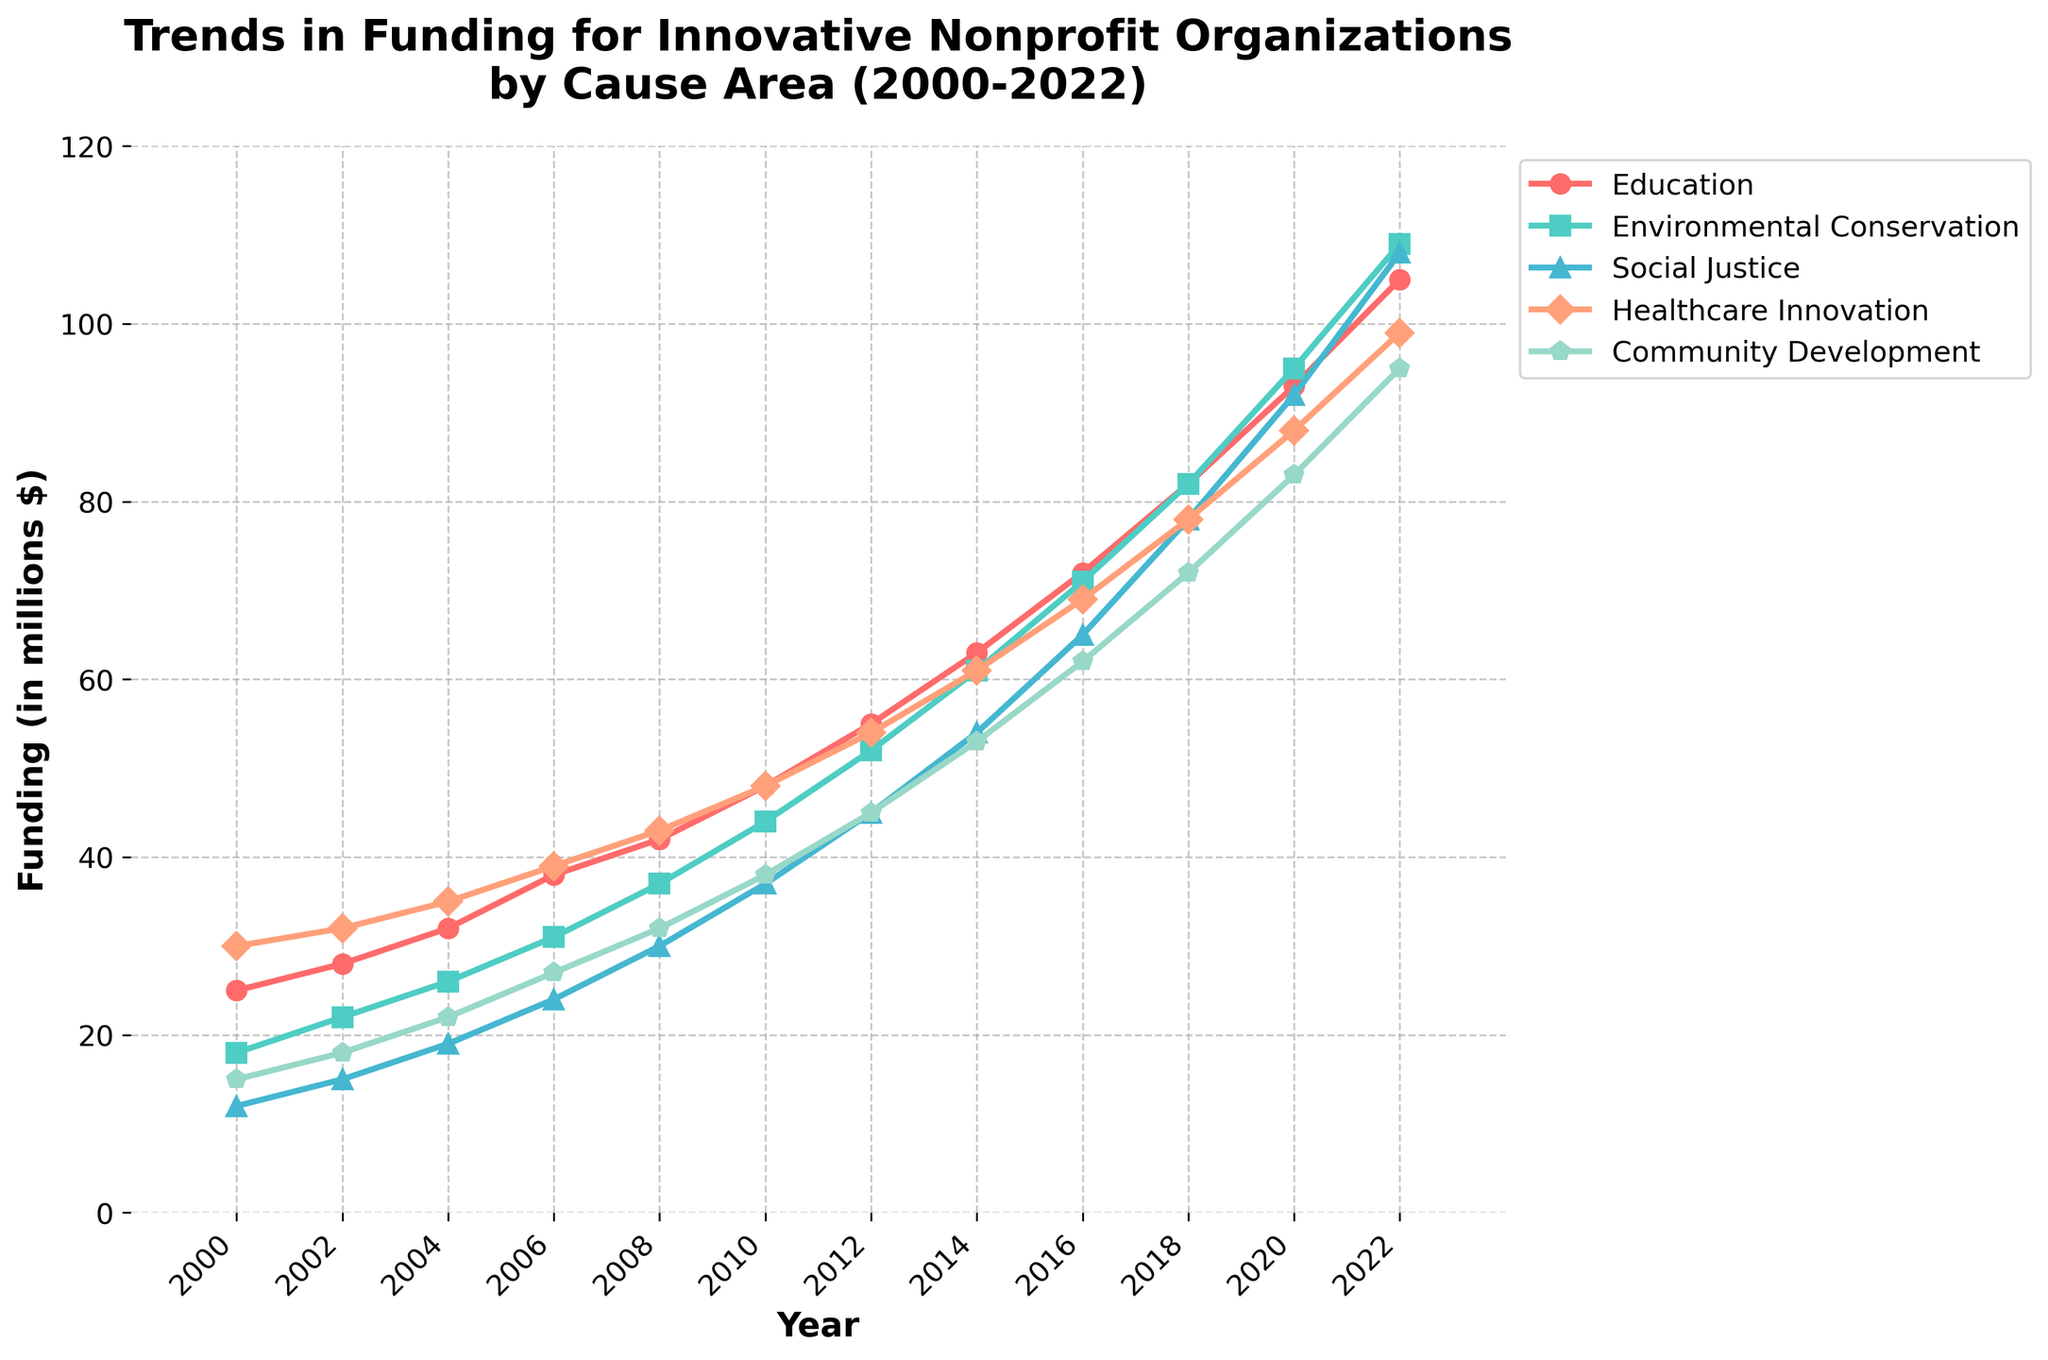What was the funding difference between Education and Healthcare Innovation in 2022? First, check the funding amounts for Education and Healthcare Innovation in 2022. Education has 105 million, and Healthcare Innovation has 99 million. The difference is: 105 - 99 = 6 million.
Answer: 6 million In which year did Environmental Conservation see the highest increase in funding compared to two years prior? Observe the data points for each year and calculate the increase from two years prior. The greatest increase is from 2020 to 2022 where the funding was 109 - 95 = 14 million.
Answer: 2022 In 2010, which cause area had the lowest funding and what was that amount? Refer to the data for 2010. Social Justice had the lowest funding with 37 million.
Answer: Social Justice, 37 million What's the difference between the highest and the lowest funding across all cause areas in 2022? Identify the highest and the lowest funding values in 2022. The highest is Environmental Conservation at 109 million, and the lowest is Social Justice at 95 million. The difference is: 109 - 95 = 14 million.
Answer: 14 million How many cause areas received more than 80 million in funding in 2020? Look at the 2020 data for each cause area. Education had 93, Environmental Conservation had 95, Social Justice had 92, and Healthcare Innovation had 88. So, there are 4 cause areas.
Answer: 4 By how much did funding for Community Development increase from 2000 to 2022? Community Development had 15 million in 2000 and 95 million in 2022. The increase is 95 - 15 = 80 million.
Answer: 80 million Which cause area showed consistent growth without any decrease from 2000 to 2022? Review each cause area to see which one shows an uninterrupted increase. Education, Environmental Conservation, Social Justice, and Healthcare Innovation all fit this pattern.
Answer: Education, Environmental Conservation, Social Justice, Healthcare Innovation Between 2012 and 2014, which cause area experienced the highest growth percentage? Calculate the growth percentage for each area from 2012 to 2014. For example, Education grew from 55 to 63 (63-55)/55=14.55%. Perform similar calculations for the others to determine that Environmental Conservation had the highest growth percentage.
Answer: Environmental Conservation What's the average annual funding for Social Justice from 2000 to 2022? Sum all the Social Justice values and divide by the number of years. (12 + 15 + 19 + 24 + 30 + 37 + 45 + 54 + 65 + 78 + 92 + 108) / 12 = 52.
Answer: 52 million Compare the trend of Community Development and Environmental Conservation: which grew at a faster rate from 2000 to 2022? Community Development increased from 15 to 95 million (80 million increase), while Environmental Conservation increased from 18 to 109 million (91 million increase). Therefore, Environmental Conservation grew at a faster rate.
Answer: Environmental Conservation 